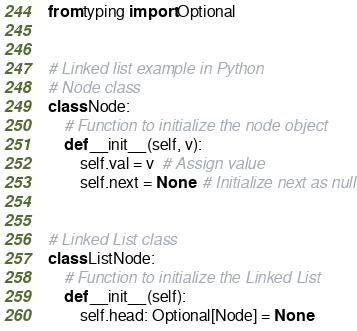<code> <loc_0><loc_0><loc_500><loc_500><_Python_>from typing import Optional


# Linked list example in Python
# Node class
class Node:
    # Function to initialize the node object
    def __init__(self, v):
        self.val = v  # Assign value
        self.next = None  # Initialize next as null


# Linked List class
class ListNode:
    # Function to initialize the Linked List
    def __init__(self):
        self.head: Optional[Node] = None
</code> 